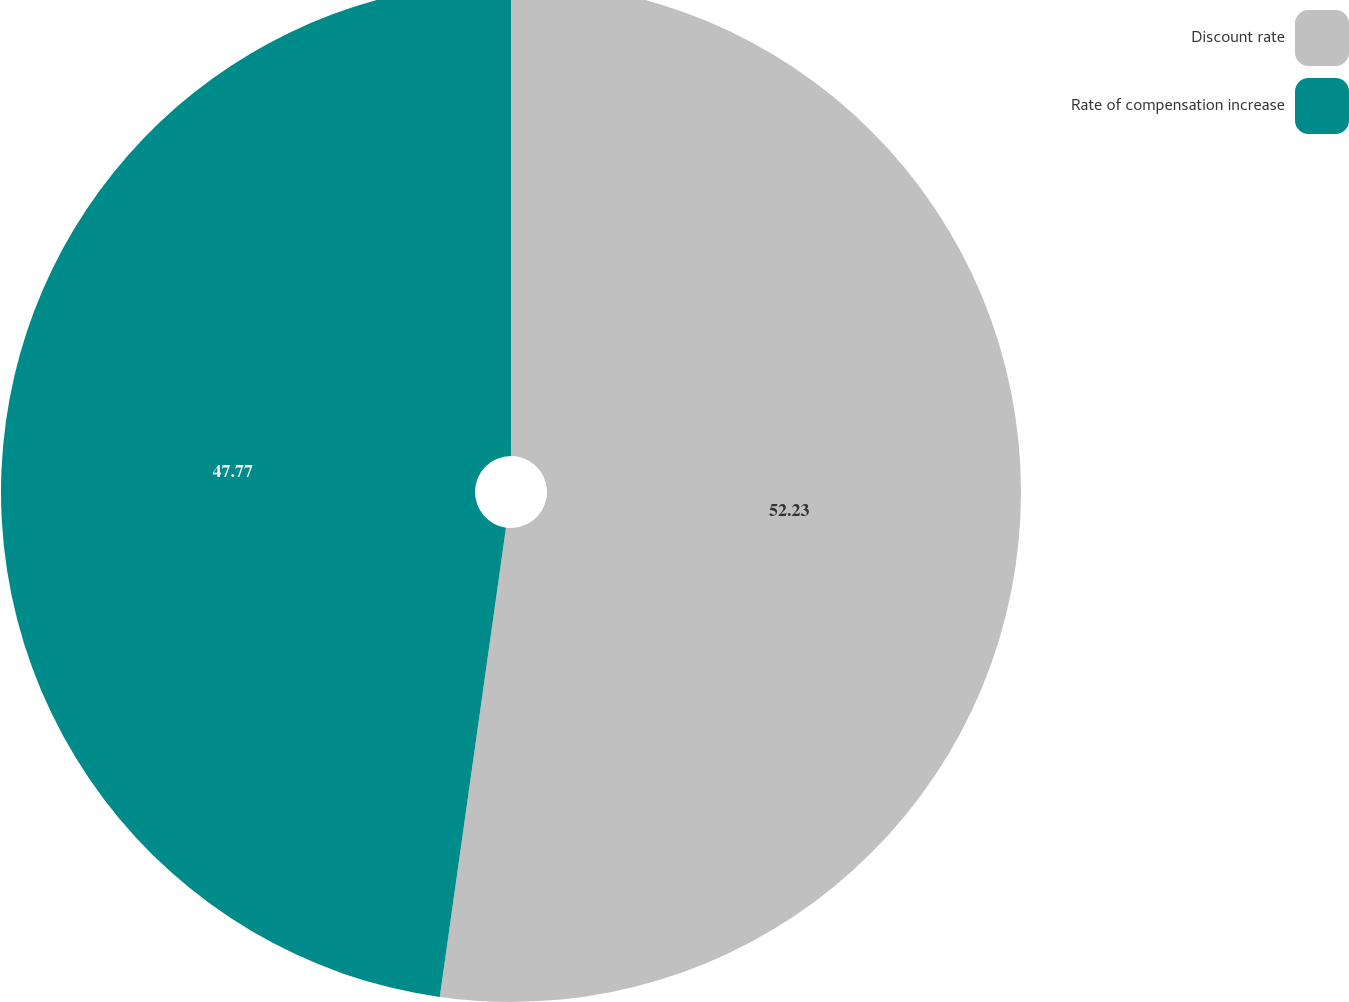<chart> <loc_0><loc_0><loc_500><loc_500><pie_chart><fcel>Discount rate<fcel>Rate of compensation increase<nl><fcel>52.23%<fcel>47.77%<nl></chart> 